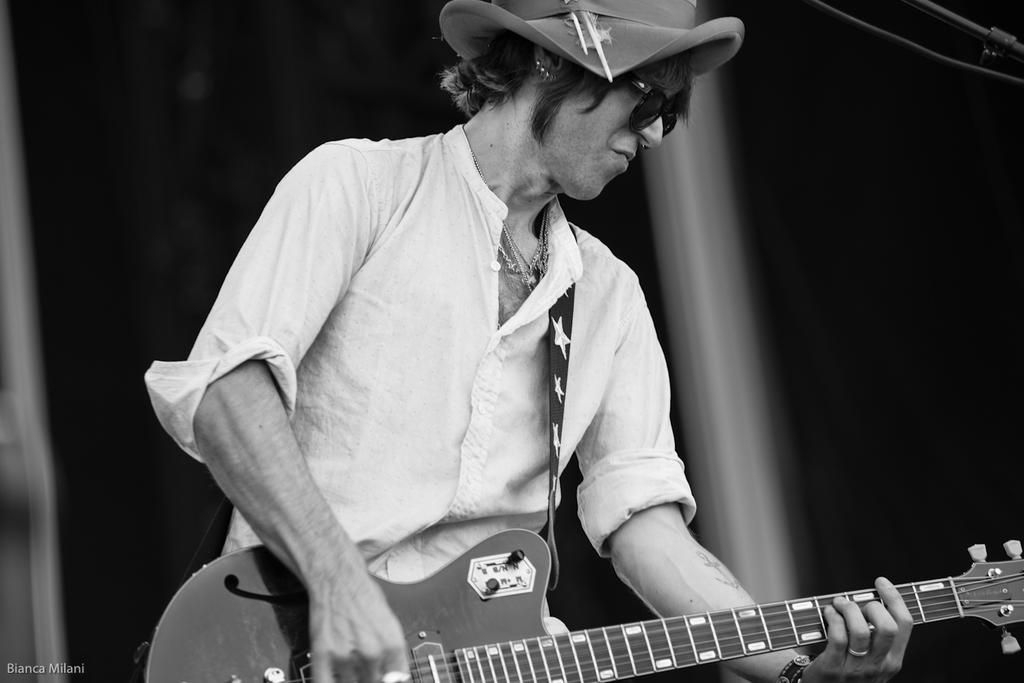What type of event is depicted in the image? The image is from a musical concert. What is the color scheme of the image? The image is black and white. What instrument is the person holding in the image? The person is holding a guitar. What accessories is the person wearing in the image? The person is wearing glasses (specs) and a hat. Where is the person located in the image? The person is in the middle of the image. What type of roll can be seen in the image? There is no roll present in the image. What is inside the crate in the image? There is no crate present in the image. 